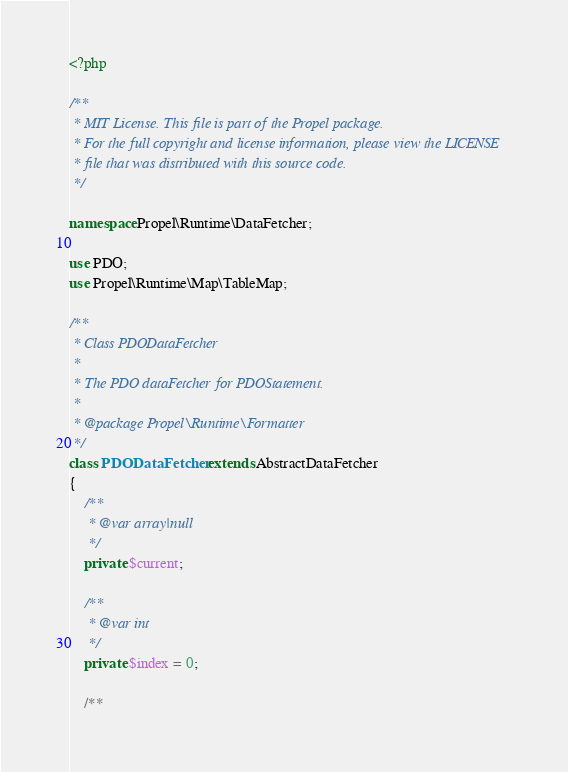Convert code to text. <code><loc_0><loc_0><loc_500><loc_500><_PHP_><?php

/**
 * MIT License. This file is part of the Propel package.
 * For the full copyright and license information, please view the LICENSE
 * file that was distributed with this source code.
 */

namespace Propel\Runtime\DataFetcher;

use PDO;
use Propel\Runtime\Map\TableMap;

/**
 * Class PDODataFetcher
 *
 * The PDO dataFetcher for PDOStatement.
 *
 * @package Propel\Runtime\Formatter
 */
class PDODataFetcher extends AbstractDataFetcher
{
    /**
     * @var array|null
     */
    private $current;

    /**
     * @var int
     */
    private $index = 0;

    /**</code> 